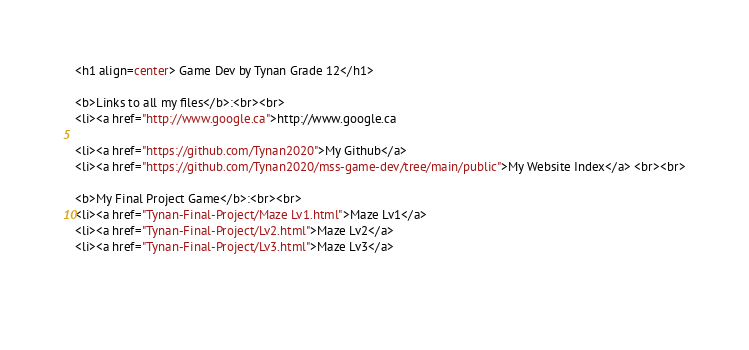Convert code to text. <code><loc_0><loc_0><loc_500><loc_500><_HTML_><h1 align=center> Game Dev by Tynan Grade 12</h1>

<b>Links to all my files</b>:<br><br>
<li><a href="http://www.google.ca">http://www.google.ca

<li><a href="https://github.com/Tynan2020">My Github</a>
<li><a href="https://github.com/Tynan2020/mss-game-dev/tree/main/public">My Website Index</a> <br><br>

<b>My Final Project Game</b>:<br><br>
<li><a href="Tynan-Final-Project/Maze Lv1.html">Maze Lv1</a>
<li><a href="Tynan-Final-Project/Lv2.html">Maze Lv2</a>
<li><a href="Tynan-Final-Project/Lv3.html">Maze Lv3</a>
  
  </code> 